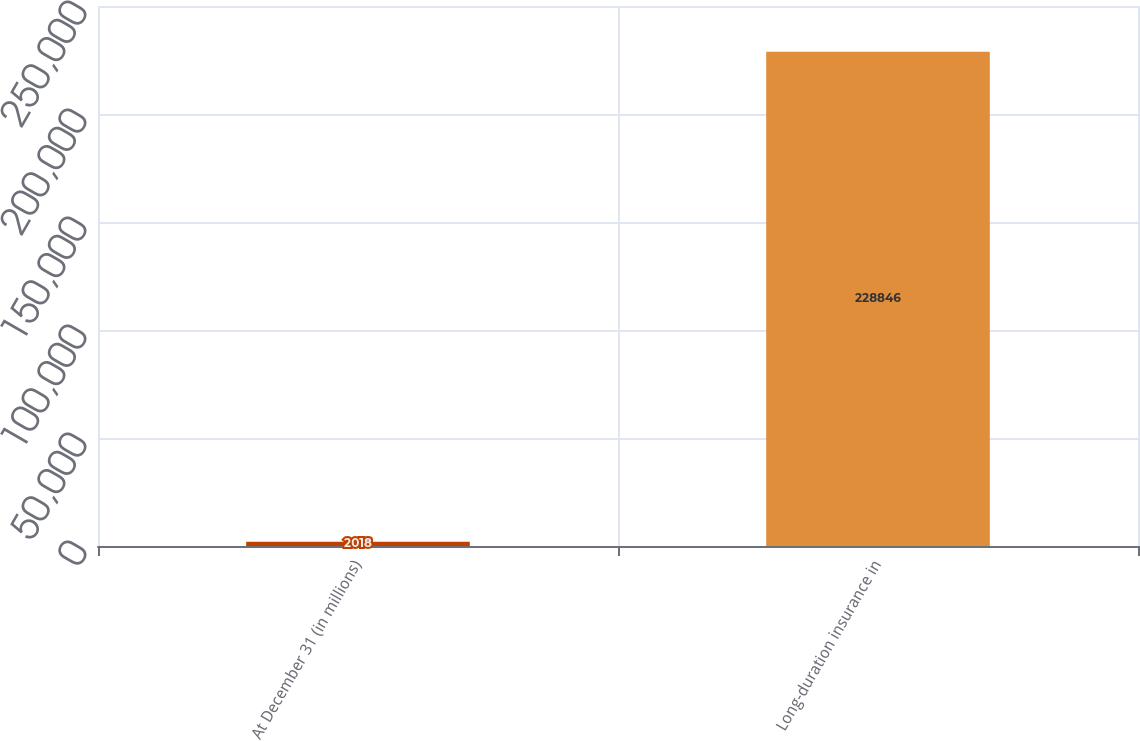Convert chart. <chart><loc_0><loc_0><loc_500><loc_500><bar_chart><fcel>At December 31 (in millions)<fcel>Long-duration insurance in<nl><fcel>2018<fcel>228846<nl></chart> 